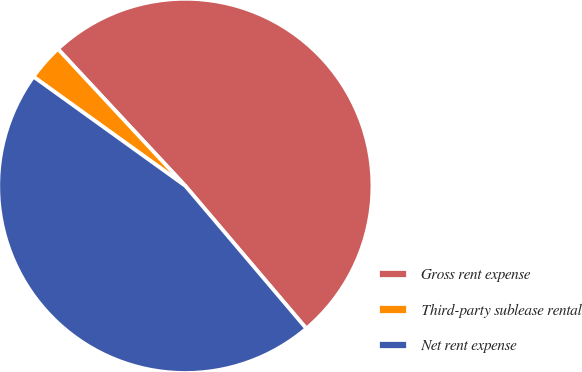Convert chart to OTSL. <chart><loc_0><loc_0><loc_500><loc_500><pie_chart><fcel>Gross rent expense<fcel>Third-party sublease rental<fcel>Net rent expense<nl><fcel>50.73%<fcel>3.15%<fcel>46.12%<nl></chart> 